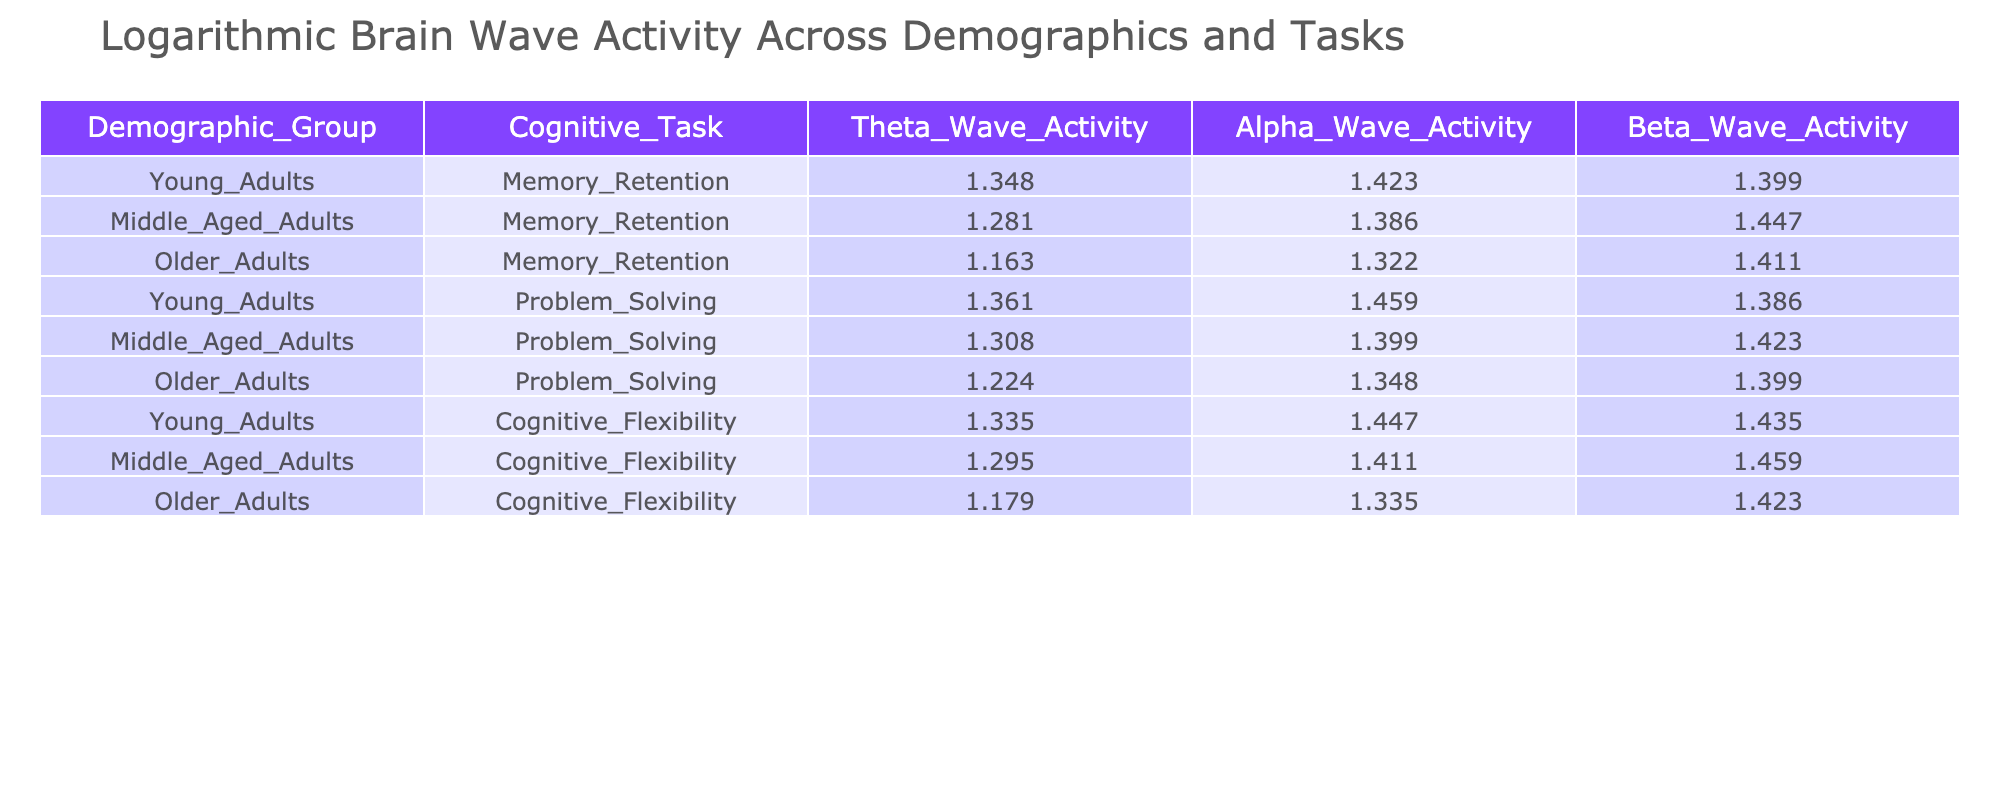What is the Theta Wave Activity for Older Adults during Memory Retention? From the table, the value for Theta Wave Activity corresponding to Older Adults in the Memory Retention task is 3.20 (logarithmic value).
Answer: 3.20 Which demographic group shows the highest Alpha Wave Activity during Problem Solving? In the Problem Solving task, Young Adults have an Alpha Wave Activity value of 4.30, which is higher than Middle Aged Adults at 4.05 and Older Adults at 3.85.
Answer: Young Adults What is the average Alpha Wave Activity for all demographic groups in the Cognitive Flexibility task? The Alpha Wave Activities for Cognitive Flexibility across the demographic groups are 4.25 (Young Adults), 4.10 (Middle Aged Adults), and 3.80 (Older Adults). To find the average, calculate (4.25 + 4.10 + 3.80) / 3 = 4.05.
Answer: 4.05 Is it true that Middle Aged Adults have a lower Beta Wave Activity than Older Adults during the Cognitive Flexibility task? For Middle Aged Adults, Beta Wave Activity is 4.30, while for Older Adults, it is 4.15. Since 4.30 is greater than 4.15, the statement is false.
Answer: No Calculate the difference in Theta Wave Activity between Young Adults and Older Adults during Problem Solving. The Theta Wave Activity for Young Adults is 3.90 and for Older Adults it is 3.40. The difference is 3.90 - 3.40 = 0.50.
Answer: 0.50 What is the lowest measured Beta Wave Activity across all demographic groups and tasks? By examining the Beta Wave Activities across all entries in the table, the lowest value is 4.00, which appears in two tasks for Young Adults and Middle Aged Adults.
Answer: 4.00 Do Younger Adults have a higher Theta Wave Activity than Older Adults during all tasks? For Memory Retention, Young Adults (3.85) are higher than Older Adults (3.20). For Problem Solving, Young Adults (3.90) are higher than Older Adults (3.40). In Cognitive Flexibility, Young Adults (3.80) are higher than Older Adults (3.25). Since Young Adults consistently show higher Theta Wave Activity in all tasks, the statement is true.
Answer: Yes What is the maximum Alpha Wave Activity recorded in the Memory Retention task and which group achieved it? The Alpha Wave Activities for Memory Retention are 4.15 (Young Adults), 4.00 (Middle Aged Adults), and 3.75 (Older Adults). The maximum is 4.15, achieved by Young Adults.
Answer: 4.15, Young Adults What is the average Beta Wave Activity for Middle Aged Adults across all tasks? The Beta Wave Activities for Middle Aged Adults in the three tasks are 4.25 (Memory Retention), 4.15 (Problem Solving), and 4.30 (Cognitive Flexibility). The average is (4.25 + 4.15 + 4.30) / 3 = 4.23.
Answer: 4.23 